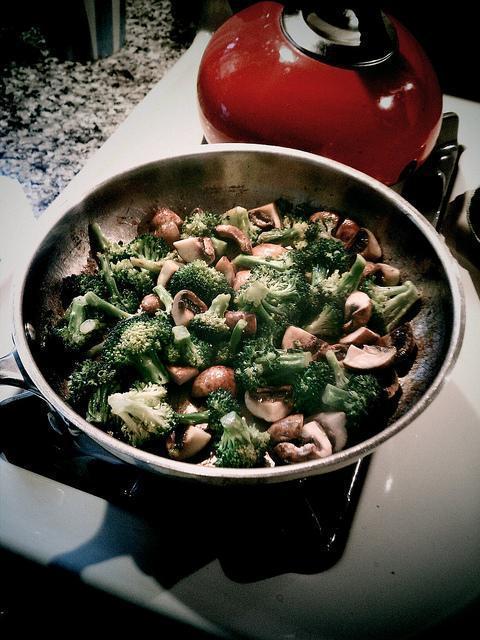How many broccolis are visible?
Give a very brief answer. 9. 